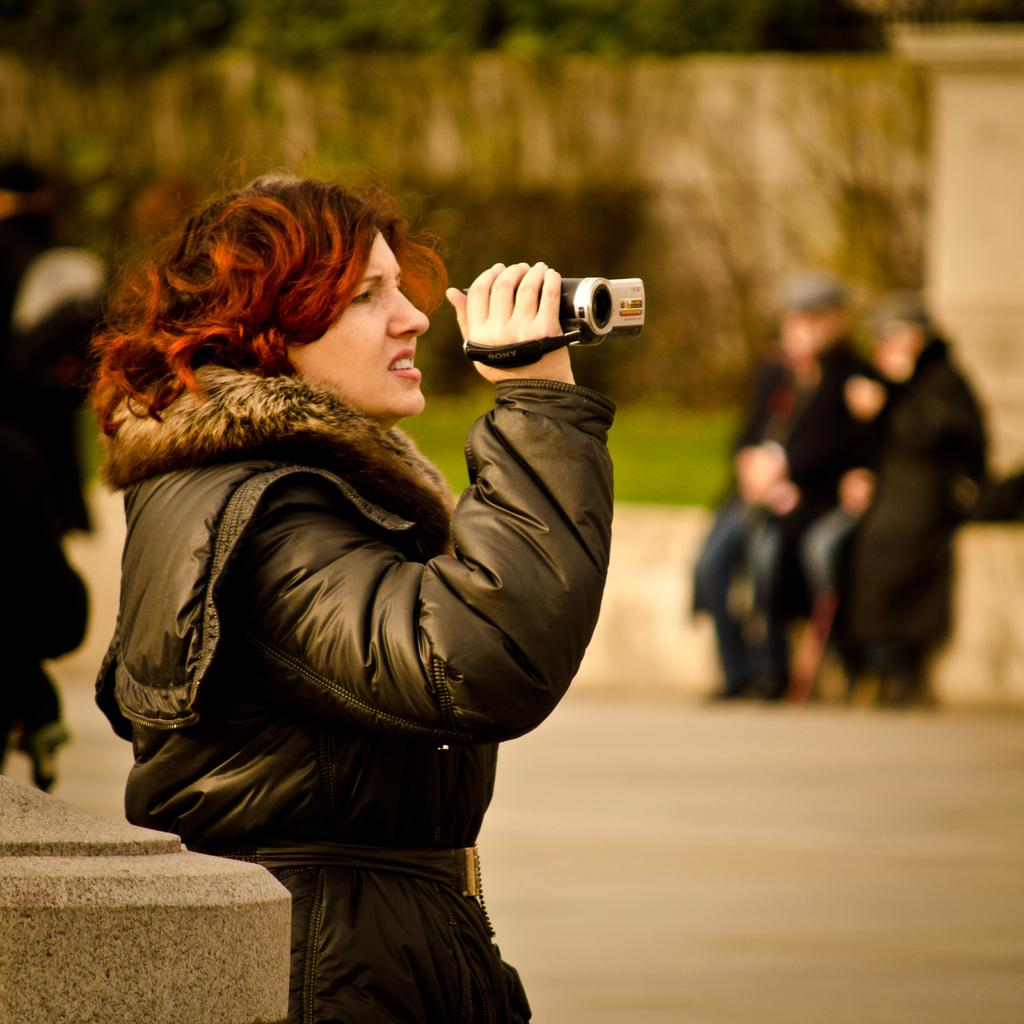Who is the main subject in the image? There is a woman in the image. What is the woman holding in the image? The woman is holding a camera. What can be seen in the background of the image? Trees, grass, and people are visible in the background of the image. What type of collar is the woman wearing in the image? There is no collar visible in the image, as the woman is wearing a camera around her neck. 